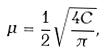Convert formula to latex. <formula><loc_0><loc_0><loc_500><loc_500>\mu = \frac { 1 } { 2 } \sqrt { \frac { 4 C } { \pi } } ,</formula> 